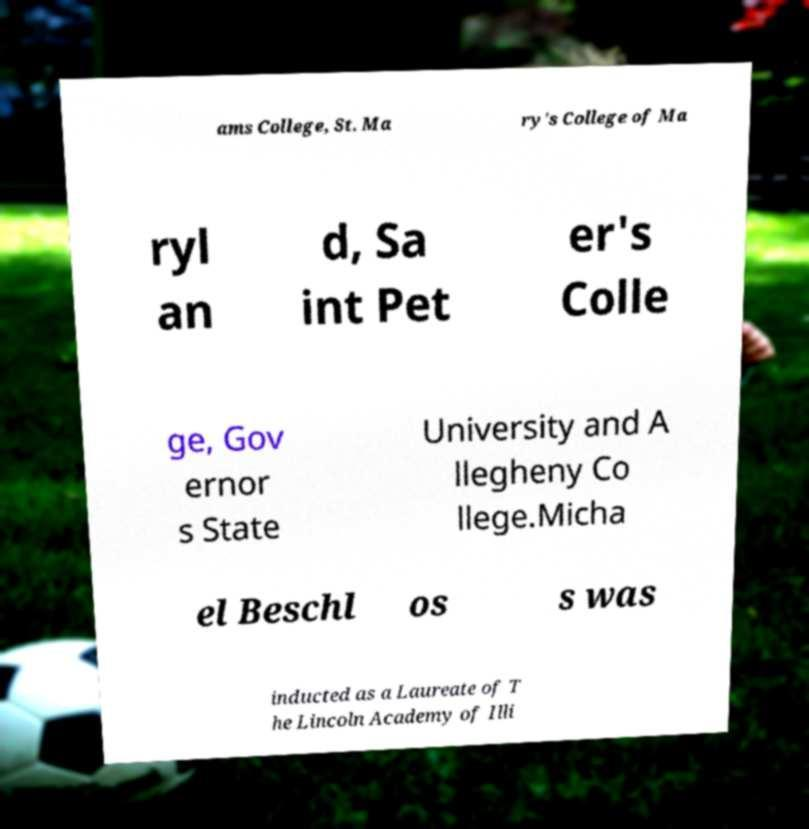Can you read and provide the text displayed in the image?This photo seems to have some interesting text. Can you extract and type it out for me? ams College, St. Ma ry's College of Ma ryl an d, Sa int Pet er's Colle ge, Gov ernor s State University and A llegheny Co llege.Micha el Beschl os s was inducted as a Laureate of T he Lincoln Academy of Illi 